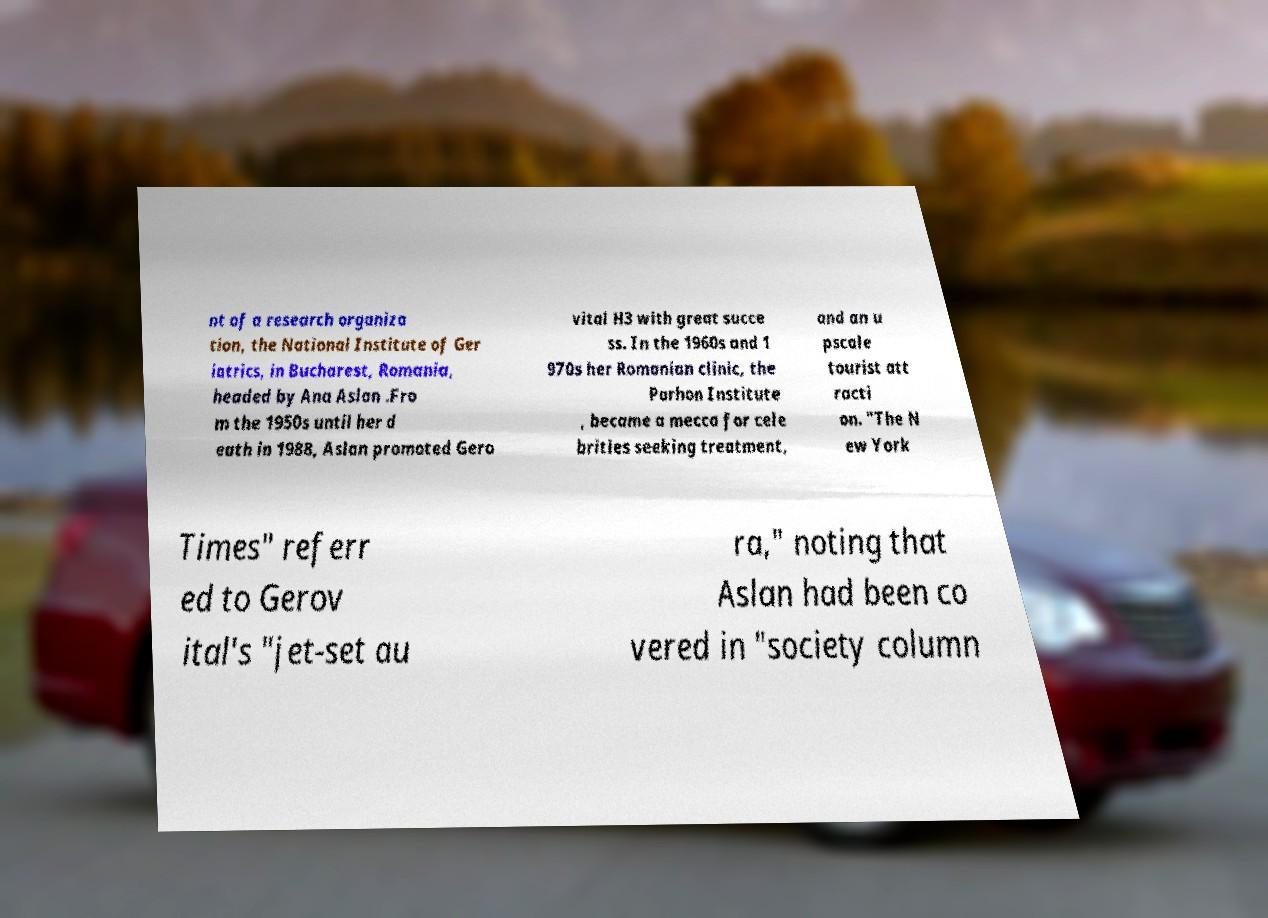Can you read and provide the text displayed in the image?This photo seems to have some interesting text. Can you extract and type it out for me? nt of a research organiza tion, the National Institute of Ger iatrics, in Bucharest, Romania, headed by Ana Aslan .Fro m the 1950s until her d eath in 1988, Aslan promoted Gero vital H3 with great succe ss. In the 1960s and 1 970s her Romanian clinic, the Parhon Institute , became a mecca for cele brities seeking treatment, and an u pscale tourist att racti on. "The N ew York Times" referr ed to Gerov ital's "jet-set au ra," noting that Aslan had been co vered in "society column 